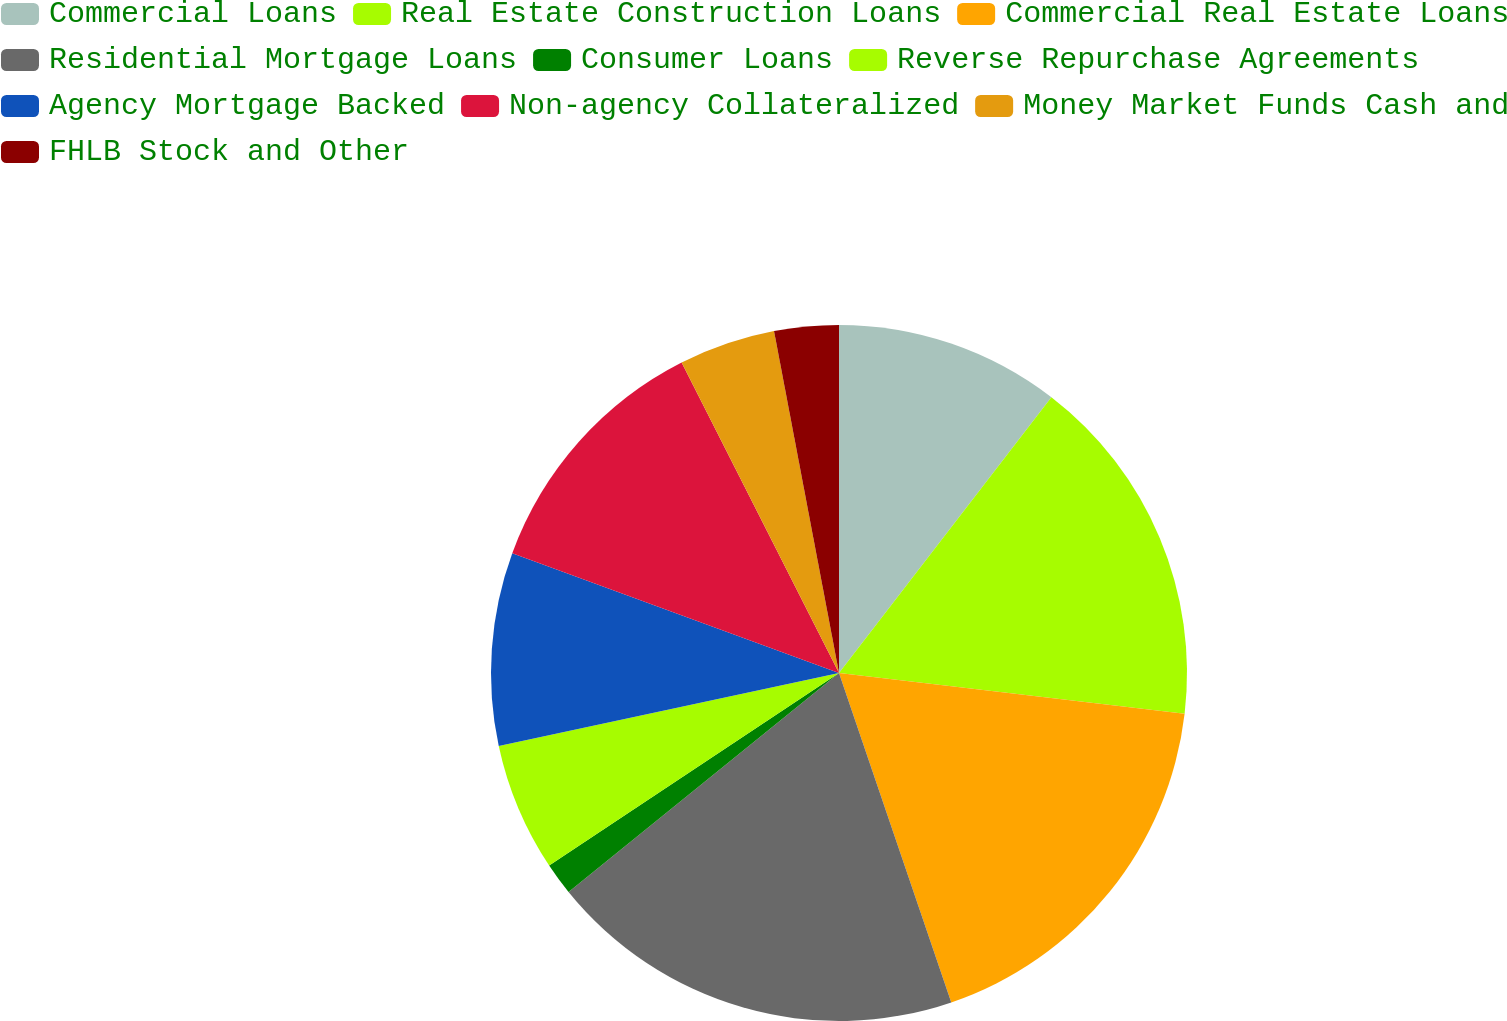Convert chart to OTSL. <chart><loc_0><loc_0><loc_500><loc_500><pie_chart><fcel>Commercial Loans<fcel>Real Estate Construction Loans<fcel>Commercial Real Estate Loans<fcel>Residential Mortgage Loans<fcel>Consumer Loans<fcel>Reverse Repurchase Agreements<fcel>Agency Mortgage Backed<fcel>Non-agency Collateralized<fcel>Money Market Funds Cash and<fcel>FHLB Stock and Other<nl><fcel>10.45%<fcel>16.42%<fcel>17.91%<fcel>19.4%<fcel>1.5%<fcel>5.97%<fcel>8.96%<fcel>11.94%<fcel>4.48%<fcel>2.99%<nl></chart> 